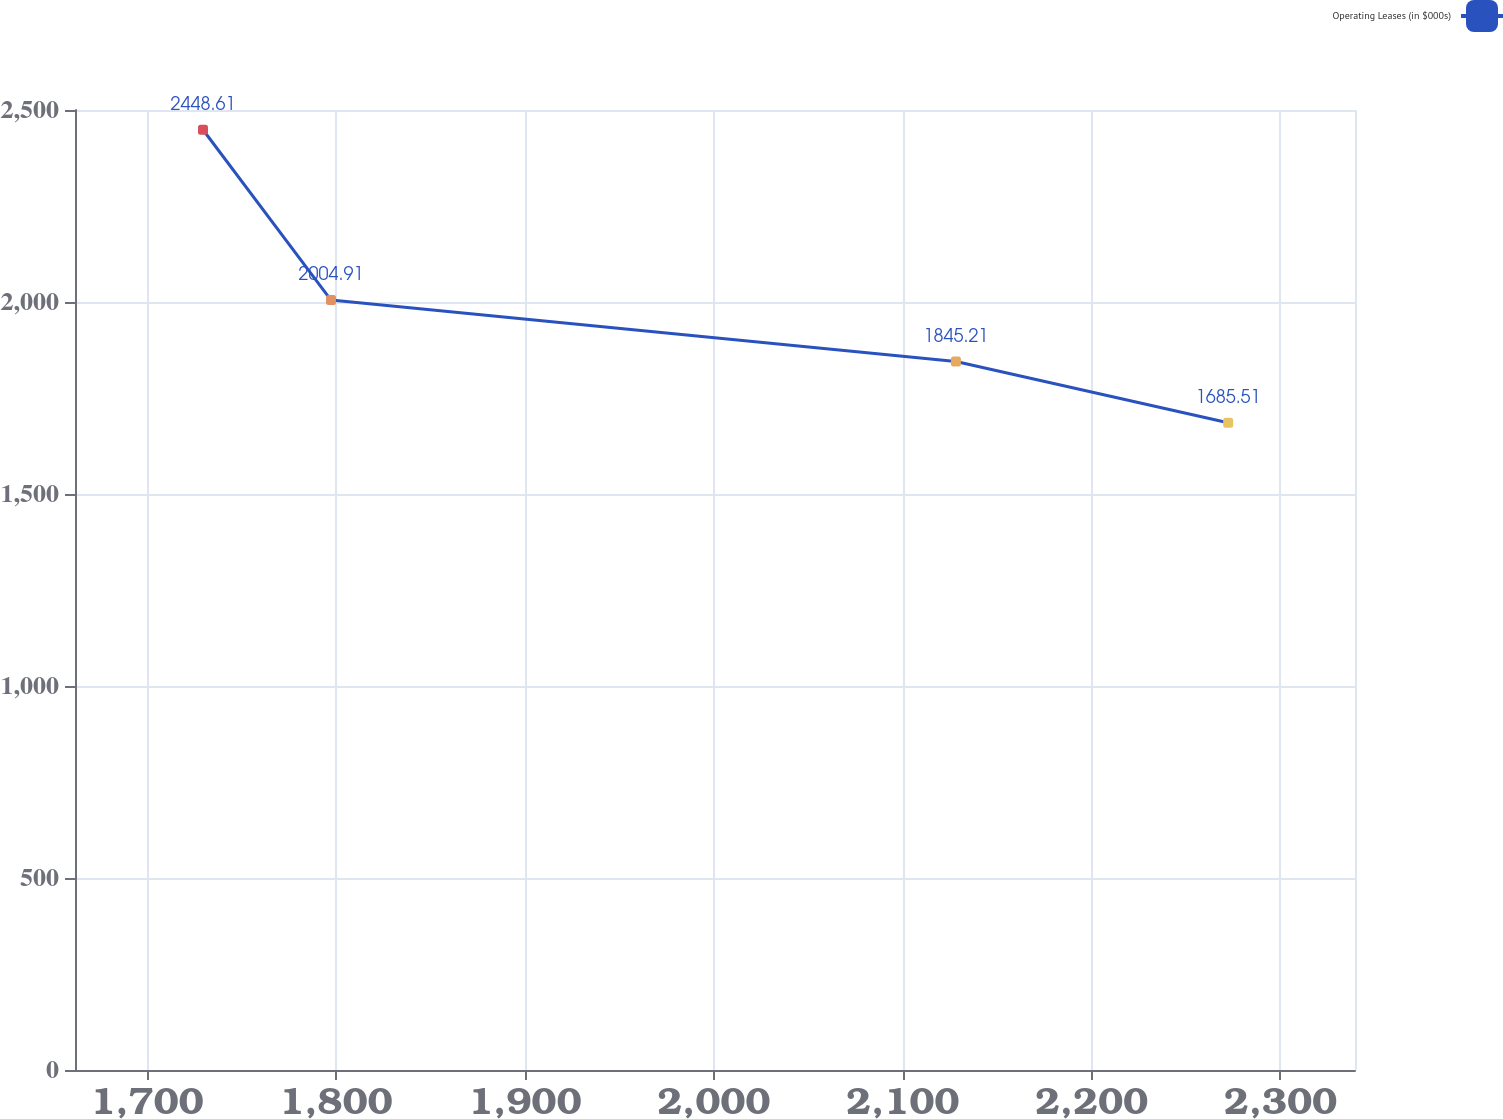<chart> <loc_0><loc_0><loc_500><loc_500><line_chart><ecel><fcel>Operating Leases (in $000s)<nl><fcel>1729.62<fcel>2448.61<nl><fcel>1797.38<fcel>2004.91<nl><fcel>2128.19<fcel>1845.21<nl><fcel>2272.3<fcel>1685.51<nl><fcel>2407.21<fcel>851.57<nl></chart> 